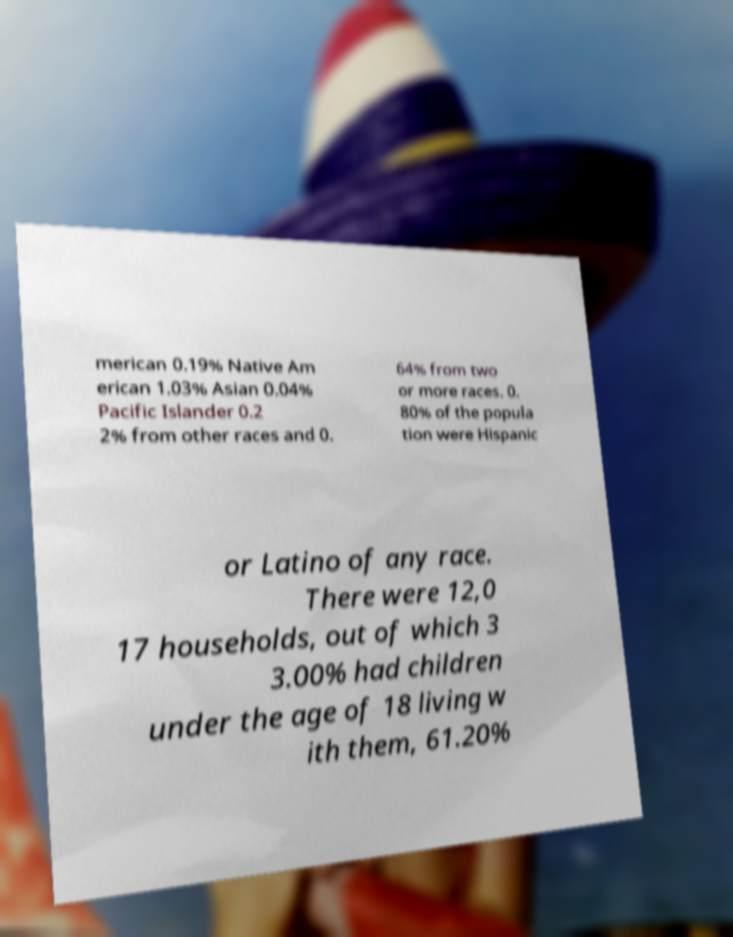Can you read and provide the text displayed in the image?This photo seems to have some interesting text. Can you extract and type it out for me? merican 0.19% Native Am erican 1.03% Asian 0.04% Pacific Islander 0.2 2% from other races and 0. 64% from two or more races. 0. 80% of the popula tion were Hispanic or Latino of any race. There were 12,0 17 households, out of which 3 3.00% had children under the age of 18 living w ith them, 61.20% 